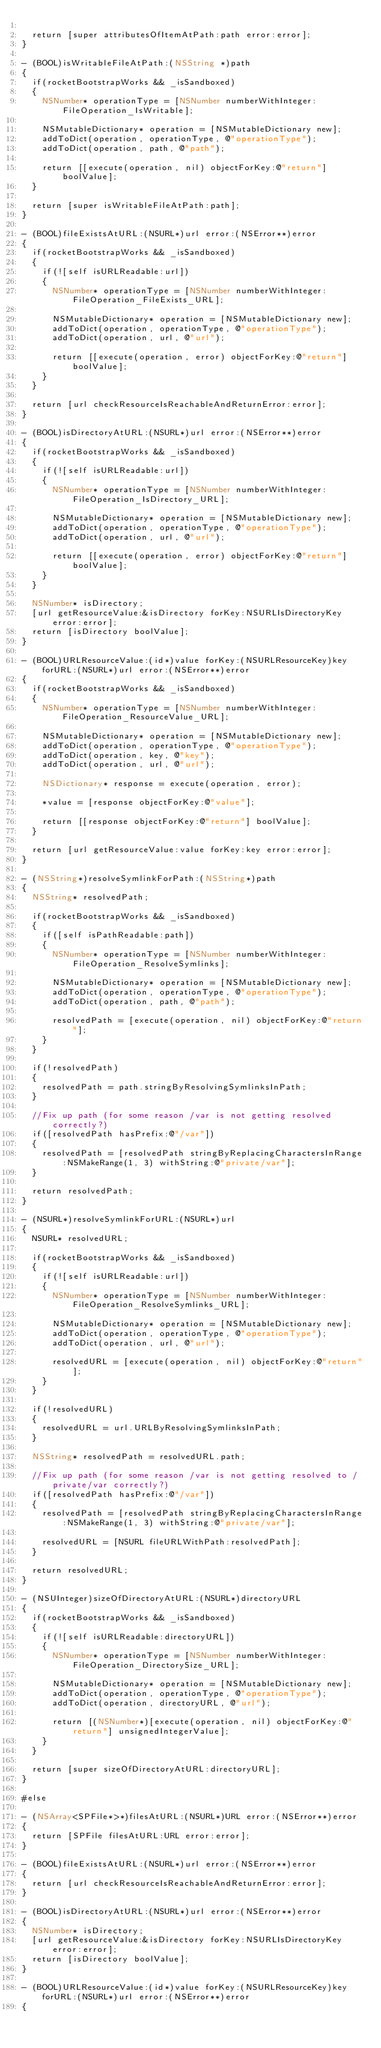Convert code to text. <code><loc_0><loc_0><loc_500><loc_500><_ObjectiveC_>
	return [super attributesOfItemAtPath:path error:error];
}

- (BOOL)isWritableFileAtPath:(NSString *)path
{
	if(rocketBootstrapWorks && _isSandboxed)
	{
		NSNumber* operationType = [NSNumber numberWithInteger:FileOperation_IsWritable];

		NSMutableDictionary* operation = [NSMutableDictionary new];
		addToDict(operation, operationType, @"operationType");
		addToDict(operation, path, @"path");

		return [[execute(operation, nil) objectForKey:@"return"] boolValue];
	}

	return [super isWritableFileAtPath:path];
}

- (BOOL)fileExistsAtURL:(NSURL*)url error:(NSError**)error
{
	if(rocketBootstrapWorks && _isSandboxed)
	{
		if(![self isURLReadable:url])
		{
			NSNumber* operationType = [NSNumber numberWithInteger:FileOperation_FileExists_URL];

			NSMutableDictionary* operation = [NSMutableDictionary new];
			addToDict(operation, operationType, @"operationType");
			addToDict(operation, url, @"url");

			return [[execute(operation, error) objectForKey:@"return"] boolValue];
		}
	}

	return [url checkResourceIsReachableAndReturnError:error];
}

- (BOOL)isDirectoryAtURL:(NSURL*)url error:(NSError**)error
{
	if(rocketBootstrapWorks && _isSandboxed)
	{
		if(![self isURLReadable:url])
		{
			NSNumber* operationType = [NSNumber numberWithInteger:FileOperation_IsDirectory_URL];

			NSMutableDictionary* operation = [NSMutableDictionary new];
			addToDict(operation, operationType, @"operationType");
			addToDict(operation, url, @"url");

			return [[execute(operation, error) objectForKey:@"return"] boolValue];
		}
	}

	NSNumber* isDirectory;
	[url getResourceValue:&isDirectory forKey:NSURLIsDirectoryKey error:error];
	return [isDirectory boolValue];
}

- (BOOL)URLResourceValue:(id*)value forKey:(NSURLResourceKey)key forURL:(NSURL*)url error:(NSError**)error
{
	if(rocketBootstrapWorks && _isSandboxed)
	{
		NSNumber* operationType = [NSNumber numberWithInteger:FileOperation_ResourceValue_URL];

		NSMutableDictionary* operation = [NSMutableDictionary new];
		addToDict(operation, operationType, @"operationType");
		addToDict(operation, key, @"key");
		addToDict(operation, url, @"url");

		NSDictionary* response = execute(operation, error);

		*value = [response objectForKey:@"value"];

		return [[response objectForKey:@"return"] boolValue];
	}

	return [url getResourceValue:value forKey:key error:error];
}

- (NSString*)resolveSymlinkForPath:(NSString*)path
{
	NSString* resolvedPath;

	if(rocketBootstrapWorks && _isSandboxed)
	{
		if([self isPathReadable:path])
		{
			NSNumber* operationType = [NSNumber numberWithInteger:FileOperation_ResolveSymlinks];

			NSMutableDictionary* operation = [NSMutableDictionary new];
			addToDict(operation, operationType, @"operationType");
			addToDict(operation, path, @"path");

			resolvedPath = [execute(operation, nil) objectForKey:@"return"];
		}
	}

	if(!resolvedPath)
	{
		resolvedPath = path.stringByResolvingSymlinksInPath;
	}

	//Fix up path (for some reason /var is not getting resolved correctly?)
	if([resolvedPath hasPrefix:@"/var"])
	{
		resolvedPath = [resolvedPath stringByReplacingCharactersInRange:NSMakeRange(1, 3) withString:@"private/var"];
	}

	return resolvedPath;
}

- (NSURL*)resolveSymlinkForURL:(NSURL*)url
{
	NSURL* resolvedURL;

	if(rocketBootstrapWorks && _isSandboxed)
	{
		if(![self isURLReadable:url])
		{
			NSNumber* operationType = [NSNumber numberWithInteger:FileOperation_ResolveSymlinks_URL];

			NSMutableDictionary* operation = [NSMutableDictionary new];
			addToDict(operation, operationType, @"operationType");
			addToDict(operation, url, @"url");

			resolvedURL = [execute(operation, nil) objectForKey:@"return"];
		}
	}

	if(!resolvedURL)
	{
		resolvedURL = url.URLByResolvingSymlinksInPath;
	}

	NSString* resolvedPath = resolvedURL.path;

	//Fix up path (for some reason /var is not getting resolved to /private/var correctly?)
	if([resolvedPath hasPrefix:@"/var"])
	{
		resolvedPath = [resolvedPath stringByReplacingCharactersInRange:NSMakeRange(1, 3) withString:@"private/var"];

		resolvedURL = [NSURL fileURLWithPath:resolvedPath];
	}

	return resolvedURL;
}

- (NSUInteger)sizeOfDirectoryAtURL:(NSURL*)directoryURL
{
	if(rocketBootstrapWorks && _isSandboxed)
	{
		if(![self isURLReadable:directoryURL])
		{
			NSNumber* operationType = [NSNumber numberWithInteger:FileOperation_DirectorySize_URL];

			NSMutableDictionary* operation = [NSMutableDictionary new];
			addToDict(operation, operationType, @"operationType");
			addToDict(operation, directoryURL, @"url");

			return [(NSNumber*)[execute(operation, nil) objectForKey:@"return"] unsignedIntegerValue];
		}
	}

	return [super sizeOfDirectoryAtURL:directoryURL];
}

#else

- (NSArray<SPFile*>*)filesAtURL:(NSURL*)URL error:(NSError**)error
{
	return [SPFile filesAtURL:URL error:error];
}

- (BOOL)fileExistsAtURL:(NSURL*)url error:(NSError**)error
{
	return [url checkResourceIsReachableAndReturnError:error];
}

- (BOOL)isDirectoryAtURL:(NSURL*)url error:(NSError**)error
{
	NSNumber* isDirectory;
	[url getResourceValue:&isDirectory forKey:NSURLIsDirectoryKey error:error];
	return [isDirectory boolValue];
}

- (BOOL)URLResourceValue:(id*)value forKey:(NSURLResourceKey)key forURL:(NSURL*)url error:(NSError**)error
{</code> 